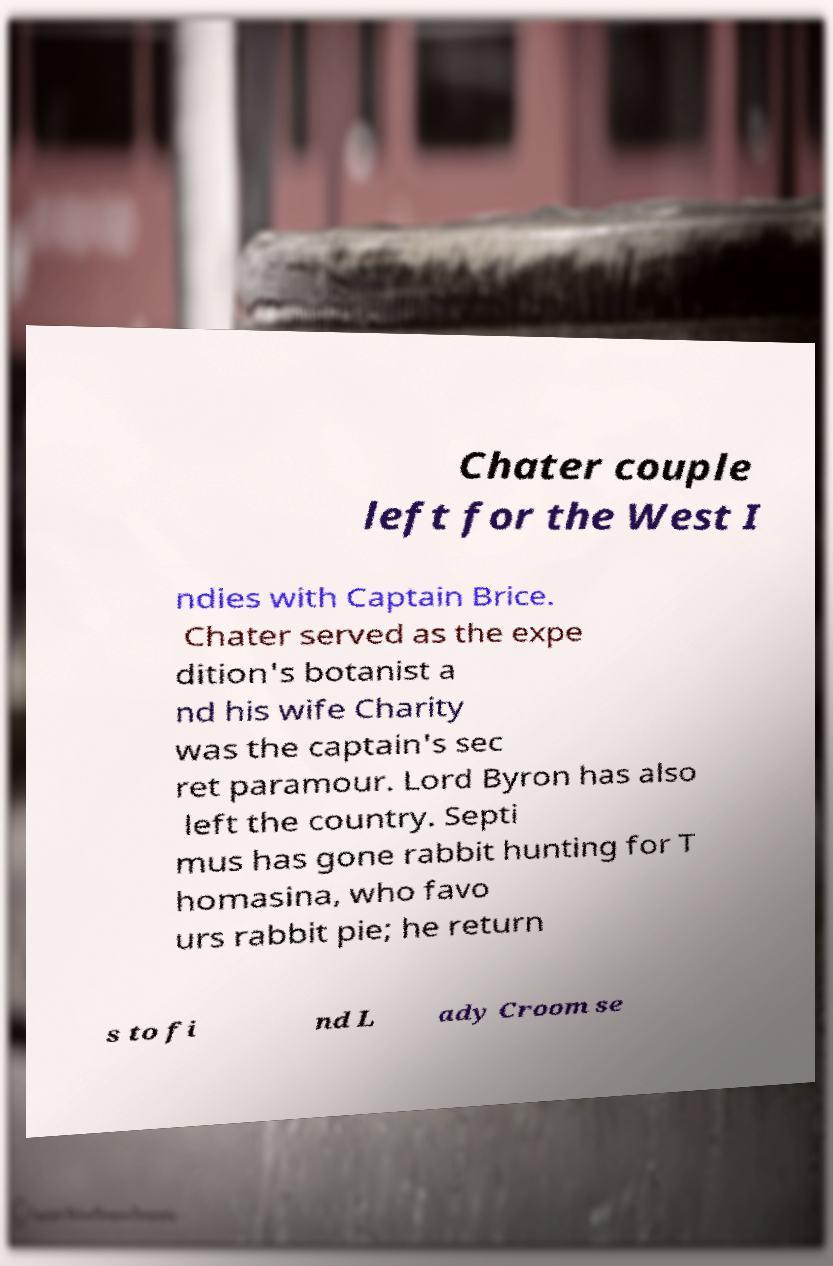Please identify and transcribe the text found in this image. Chater couple left for the West I ndies with Captain Brice. Chater served as the expe dition's botanist a nd his wife Charity was the captain's sec ret paramour. Lord Byron has also left the country. Septi mus has gone rabbit hunting for T homasina, who favo urs rabbit pie; he return s to fi nd L ady Croom se 